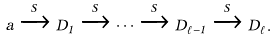Convert formula to latex. <formula><loc_0><loc_0><loc_500><loc_500>a \xrightarrow { S } D _ { 1 } \xrightarrow { S } \cdots \xrightarrow { S } D _ { \ell - 1 } \xrightarrow { S } D _ { \ell } .</formula> 